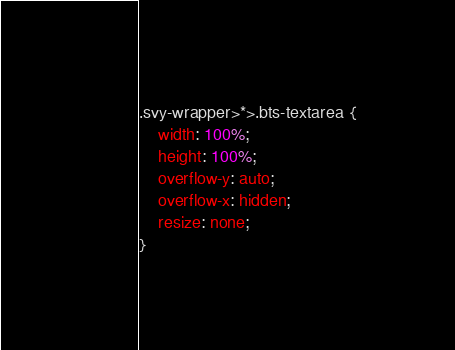Convert code to text. <code><loc_0><loc_0><loc_500><loc_500><_CSS_>.svy-wrapper>*>.bts-textarea {
	width: 100%;
	height: 100%;
	overflow-y: auto;
	overflow-x: hidden;
	resize: none;
}</code> 